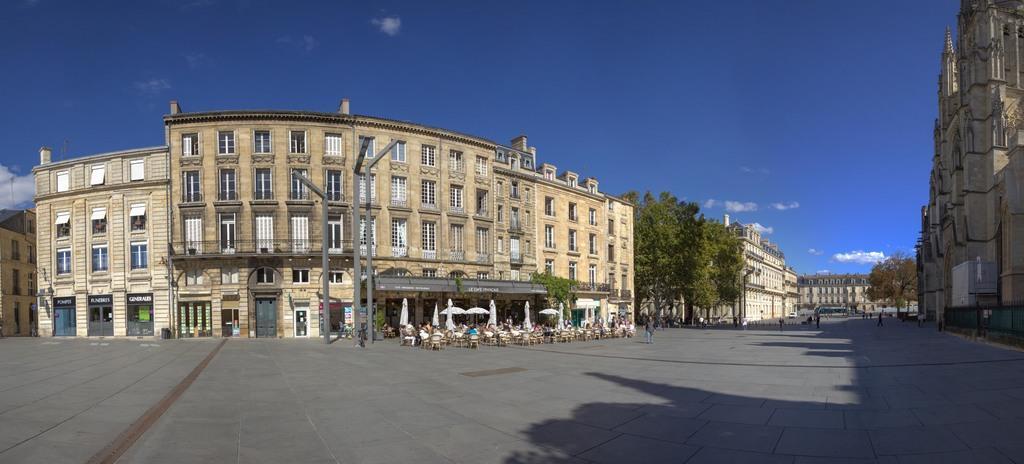In one or two sentences, can you explain what this image depicts? In this image we can see the road, people walking here, we can see tables, chairs, light poles, stone buildings, trees and the blue color sky in the background. 